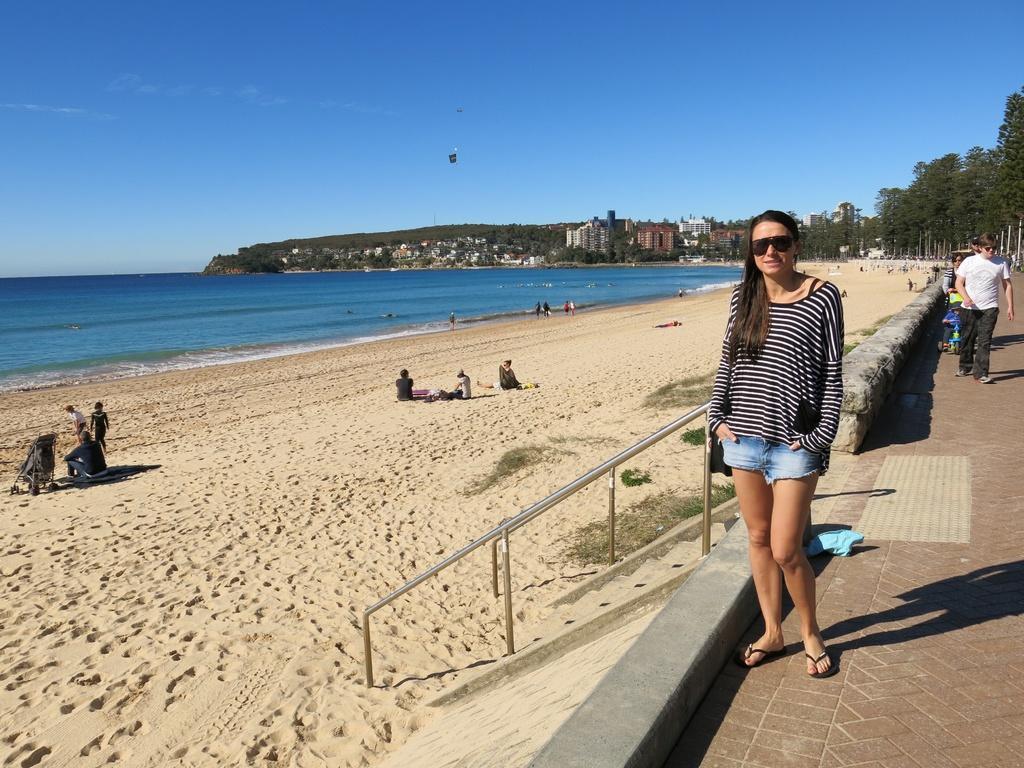Could you give a brief overview of what you see in this image? This is a beach. On the left side there are few people sitting in the beach. On the right side few people are walking on the ground and a woman is standing and giving pose for the picture. On the left side there is an ocean. In the background there are many trees and buildings. At the top of the image I can see the sky in blue color. 